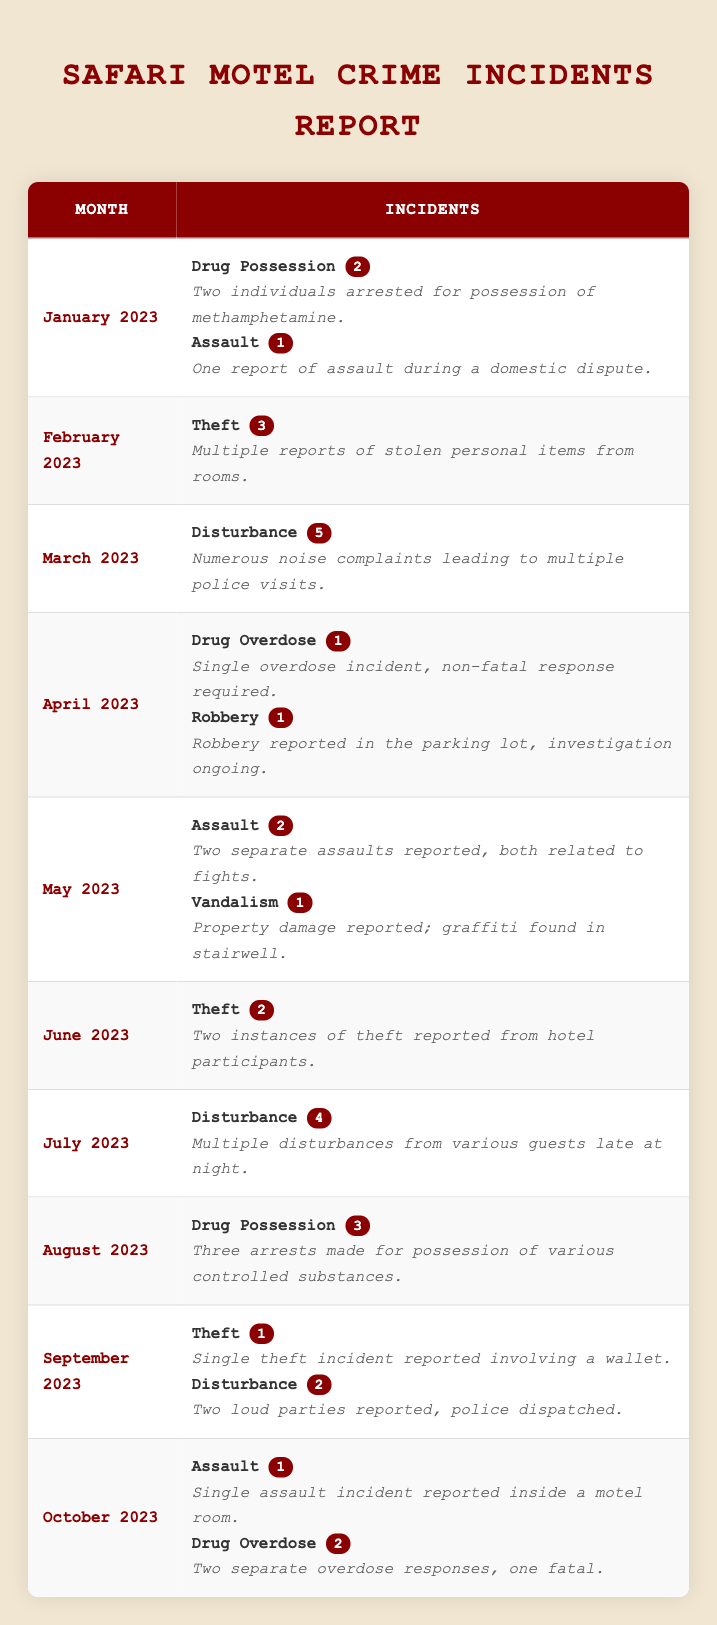What were the most common types of incidents reported at Safari Motel in 2023? By reviewing the table, I can identify the types of incidents listed each month. The types of incidents include Drug Possession, Assault, Theft, Disturbance, Drug Overdose, Robbery, and Vandalism. Drug Possession appears in January and August, Assault in January, May, and October, Theft in February, June, September, and two times in total, Disturbance in March, July, and September, Drug Overdose in April and October, Robbery in April, and Vandalism in May. Summarizing this information, Drug Possession and Disturbance are the most common incidents reported.
Answer: Drug Possession and Disturbance In which month were the most disturbances reported? The table lists disturbances for March (5), July (4), and September (2). By comparing these numbers, March has the highest number of disturbances reported at 5.
Answer: March 2023 How many total crime incidents were reported in January 2023? In January 2023, there were 2 Drug Possession incidents and 1 Assault incident. Summing these gives a total of 3 incidents (2 + 1 = 3).
Answer: 3 Was there a theft incident reported in October 2023? In October 2023, the incidents reported included Assault and Drug Overdose, but there is no mention of a Theft incident. Thus, the answer is no.
Answer: No What is the total number of Drug-related incidents reported over the months? The Drug-related incidents include 2 in January (Drug Possession), 1 in April (Drug Overdose), 3 in August (Drug Possession), and 2 in October (Drug Overdose). Adding these gives a total of 8 Drug-related incidents (2 + 1 + 3 + 2 = 8).
Answer: 8 What was the difference in the number of theft incidents between February and June? In February, there were 3 Theft incidents, while in June, there were 2. To find the difference, I subtract the number of June theft incidents from those in February: 3 - 2 = 1.
Answer: 1 How many incidents of vandalism were reported in 2023? Vandalism was reported just once in May, specifically mentioned in the details of that month. Therefore, the total count of vandalism incidents for the year is 1.
Answer: 1 Which month had the highest total reported incidents, and how many were there? To find this, I will count the total incidents for each month. The totals are: January (3), February (3), March (5), April (2), May (3), June (2), July (4), August (3), September (3), and October (3). The highest was in March with 5 reported incidents.
Answer: March 2023, 5 Was there any month without reported crime incidents? Reviewing the table, every month from January to October has at least one reported incident. Therefore, none of the months were free of reported criminal activity.
Answer: No What percentage of the incidents in October involved Drug Overdose? In October 2023, there were 3 total incidents: 1 Assault and 2 Drug Overdose incidents. To calculate the percentage of Drug Overdose incidents, I divide the number of Drug Overdose incidents by the total incidents: (2 / 3) * 100 = 66.67%.
Answer: 66.67% 